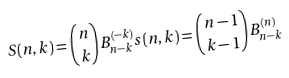<formula> <loc_0><loc_0><loc_500><loc_500>S ( n , k ) = \binom { n } { k } B _ { n - k } ^ { ( - k ) } s ( n , k ) = \binom { n - 1 } { k - 1 } B _ { n - k } ^ { ( n ) }</formula> 